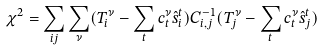Convert formula to latex. <formula><loc_0><loc_0><loc_500><loc_500>\chi ^ { 2 } = \sum _ { i j } \sum _ { \nu } ( T _ { i } ^ { \nu } - \sum _ { t } c _ { t } ^ { \nu } \hat { s } _ { i } ^ { t } ) C ^ { - 1 } _ { i , j } ( T _ { j } ^ { \nu } - \sum _ { t } c _ { t } ^ { \nu } \hat { s } _ { j } ^ { t } )</formula> 